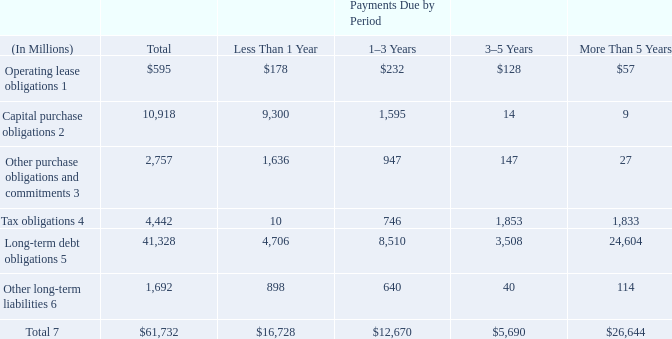CONTRACTUAL OBLIGATIONS
Significant contractual obligations as of December 28, 2019 were as follows:
1 Operating lease obligations represent the undiscounted lease payments under non-cancelable leases, but exclude non-lease components.
2 Capital purchase obligations represent commitments for the construction or purchase of property, plant and equipment. They were not recorded as liabilities on our Consolidated Balance Sheets as of December 28, 2019, as we had not yet received the related goods nor taken title to the property.
3 Other purchase obligations and commitments include payments due under various types of licenses and agreements to purchase goods or services.
4 Tax obligations represent the future cash payments related to Tax Reform enacted in 2017 for the one-time transition tax on our previously untaxed foreign earnings.
5 Amounts represent principal payments for all debt obligations and interest payments for fixed-rate debt obligations. Interest payments on floating-rate debt obligations, as well as the impact of fixed-rate to floating-rate debt swaps, are excluded. Debt obligations are classified based on their stated maturity date, regardless of their classification on the Consolidated Balance Sheets.
6 Amounts represent future cash payments to satisfy other long-term liabilities recorded on our Consolidated Balance Sheets, including the short-term portion of these long-term liabilities. Derivative instruments are excluded from the preceding table, because they do not represent the amounts that may ultimately be paid.
7 Total excludes contractual obligations already recorded on our Consolidated Balance Sheets as current liabilities, except for the short-term portions of long-term debt obligations and other long-term liabilities.
The expected timing of payments of the obligations in the preceding table is estimated based on current information. Timing of payments and actual amounts paid may be different, depending on the time of receipt of goods or services, or changes to agreed-upon amounts for some obligations.
Contractual obligations for purchases of goods or services included in “Other purchase obligations and commitments” in the preceding table include agreements that are enforceable and legally binding and that specify all significant terms, including fixed or minimum quantities to be purchased; fixed, minimum, or variable price provisions; and the approximate timing of the transaction. For obligations with cancellation provisions, the amounts included in the preceding table were limited to the non-cancelable portion of the agreement terms or the minimum cancellation fee.
For the purchase of raw materials, we have entered into certain agreements that specify minimum prices and quantities based on a percentage of the total available market or based on a percentage of our future purchasing requirements. Due to the uncertainty of the future market and our future purchasing requirements, as well as the non-binding nature of these agreements, obligations under these agreements have been excluded from the preceding table. Our purchase orders for other products are based on our current manufacturing needs and are fulfilled by our vendors within short time horizons. In addition, some of our purchase orders represent authorizations to purchase rather than binding agreements.
Contractual obligations that are contingent upon the achievement of certain milestones have been excluded from the preceding table. Approximately half of our milestone-based contracts are tooling related for the purchase of capital equipment. These arrangements are not considered contractual obligations until the milestone is met by the counterparty. As of December 28, 2019, assuming that all future milestones are met, the additional required payments would be approximately $498 million.
For the majority of RSUs granted, the number of shares of common stock issued on the date the RSUs vest is net of the minimum statutory withholding requirements that we pay in cash to the appropriate taxing authorities on behalf of our employees. The obligation to pay the relevant taxing authority is excluded from the preceding table, as the amount is contingent upon continued employment. In addition, the amount of the obligation is unknown, as it is based in part on the market price of our common stock when the awards vest.
What are the types of contractual obligations in the table? Operating lease obligations, capital purchase obligations, other purchase obligations and commitments, tax obligations, long-term debt obligations, other long-term liabilities. What payments do Other purchase obligations and commitments include? Include payments due under various types of licenses and agreements to purchase goods or services. Why are derivative instruments excluded from the preceding table? Because they do not represent the amounts that may ultimately be paid. What is the capital purchase obligations expressed as a percentage of the contractual obligations that is due in less than 1 year?
Answer scale should be: percent. 9,300/16,728
Answer: 55.6. Which Payments Due by Period has the highest total contractual obligation? For ROW9 COL4 to 7 find the largest number and the corresponding period in ROW2
Answer: more than 5 years. What is the percentage change of total liabilities due from Less than 1 year to 1-3 years?
Answer scale should be: percent. (12,670-16,728)/16,728
Answer: -24.26. 